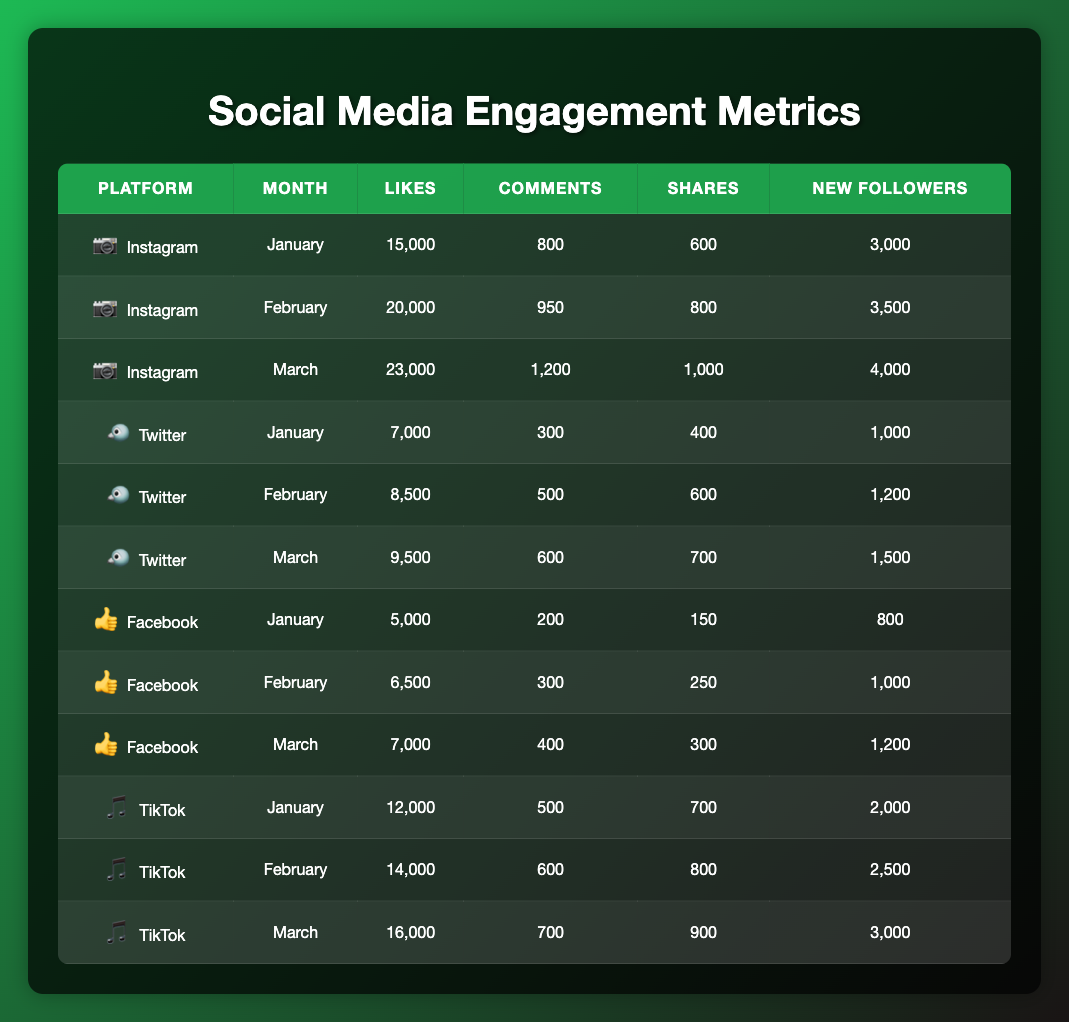What platform had the highest likes in March? In March, the likes for each platform are as follows: Instagram has 23,000, Twitter has 9,500, Facebook has 7,000, and TikTok has 16,000. Comparing these values, Instagram has the highest likes at 23,000.
Answer: Instagram What is the total number of new followers across all platforms in February? The new followers for February are: Instagram has 3,500, Twitter has 1,200, Facebook has 1,000, and TikTok has 2,500. Adding these together gives: 3,500 + 1,200 + 1,000 + 2,500 = 8,200.
Answer: 8,200 Did Facebook receive more likes than Twitter in January? In January, Facebook had 5,000 likes and Twitter had 7,000 likes. Since 5,000 is less than 7,000, Facebook did not receive more likes than Twitter.
Answer: No What is the average number of comments received on TikTok across all months? For TikTok, the comments across the three months are 500 (January), 600 (February), and 700 (March). Adding these gives 500 + 600 + 700 = 1,800. Dividing by the number of months (3) gives an average of 1,800 / 3 = 600.
Answer: 600 Which platform experienced the highest increase in new followers from January to March? The new followers for January and March are as follows: Instagram gained 3,000 in January and 4,000 in March (an increase of 1,000), Twitter gained 1,000 in January and 1,500 in March (an increase of 500), Facebook gained 800 in January and 1,200 in March (an increase of 400), and TikTok gained 2,000 in January and 3,000 in March (an increase of 1,000). Both Instagram and TikTok had the highest increases of 1,000 new followers.
Answer: Instagram and TikTok What was the total number of shares across all platforms in March? In March, the shares are: Instagram has 1,000, Twitter has 700, Facebook has 300, and TikTok has 900. Adding these gives a total of 1,000 + 700 + 300 + 900 = 2,900.
Answer: 2,900 